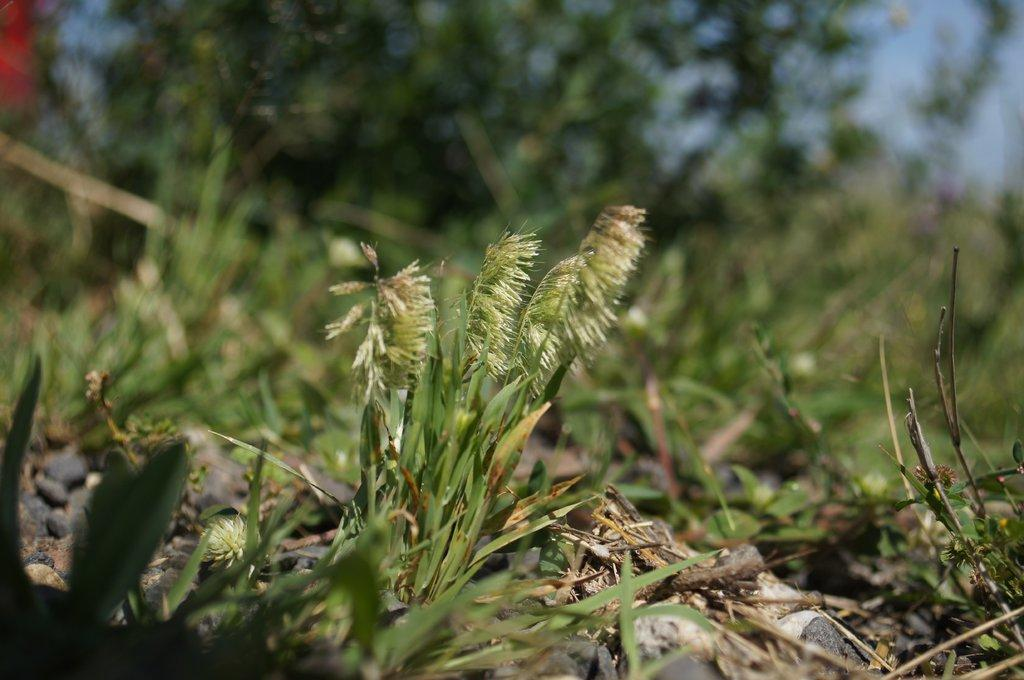What type of vegetation is present on the ground in the image? There is grass on the ground in the image. What can be seen in the background of the image? A: There are trees and the sky visible in the background of the image. How would you describe the overall quality of the image? The image is blurry. What type of mitten is hanging from the tree in the image? There is no mitten present in the image; it only features grass, trees, and the sky. How much growth has the pot experienced in the image? There is no pot present in the image, so it is not possible to determine its growth. 